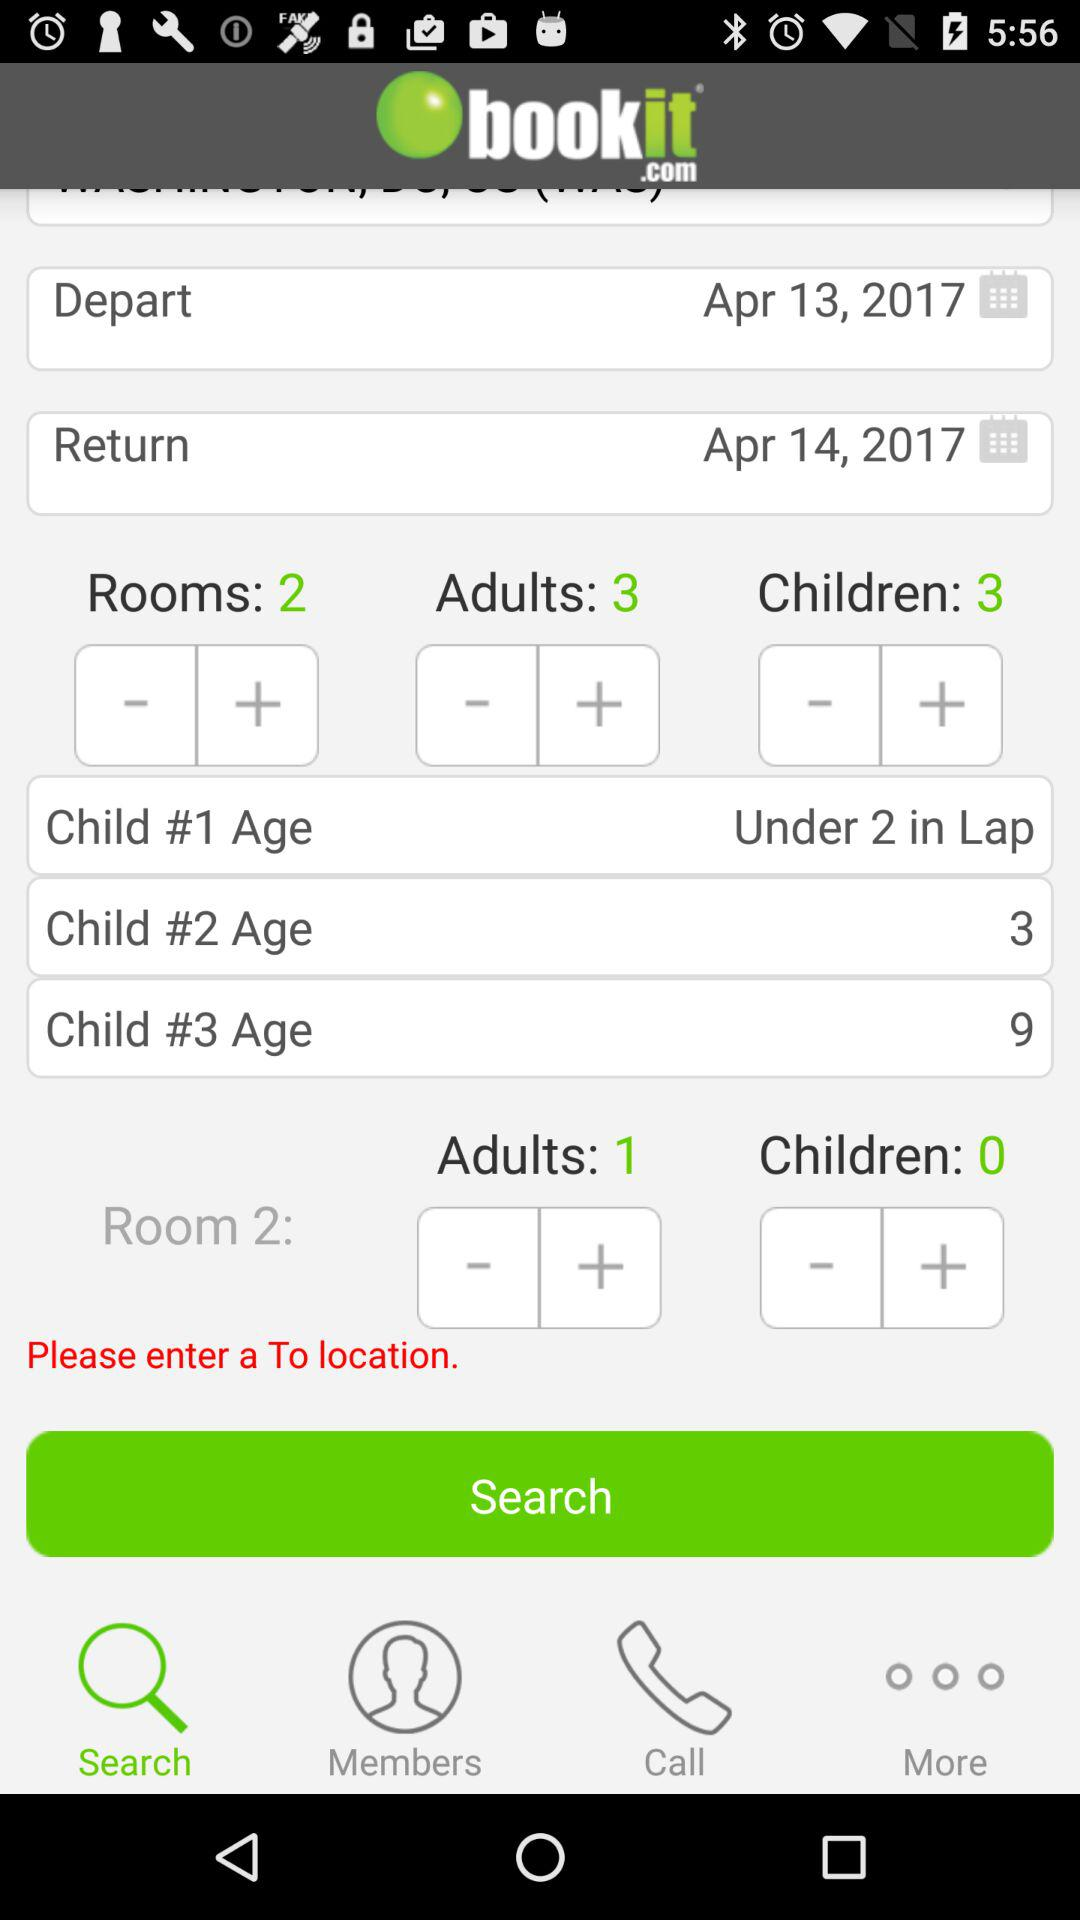How many rooms are there?
Answer the question using a single word or phrase. 2 